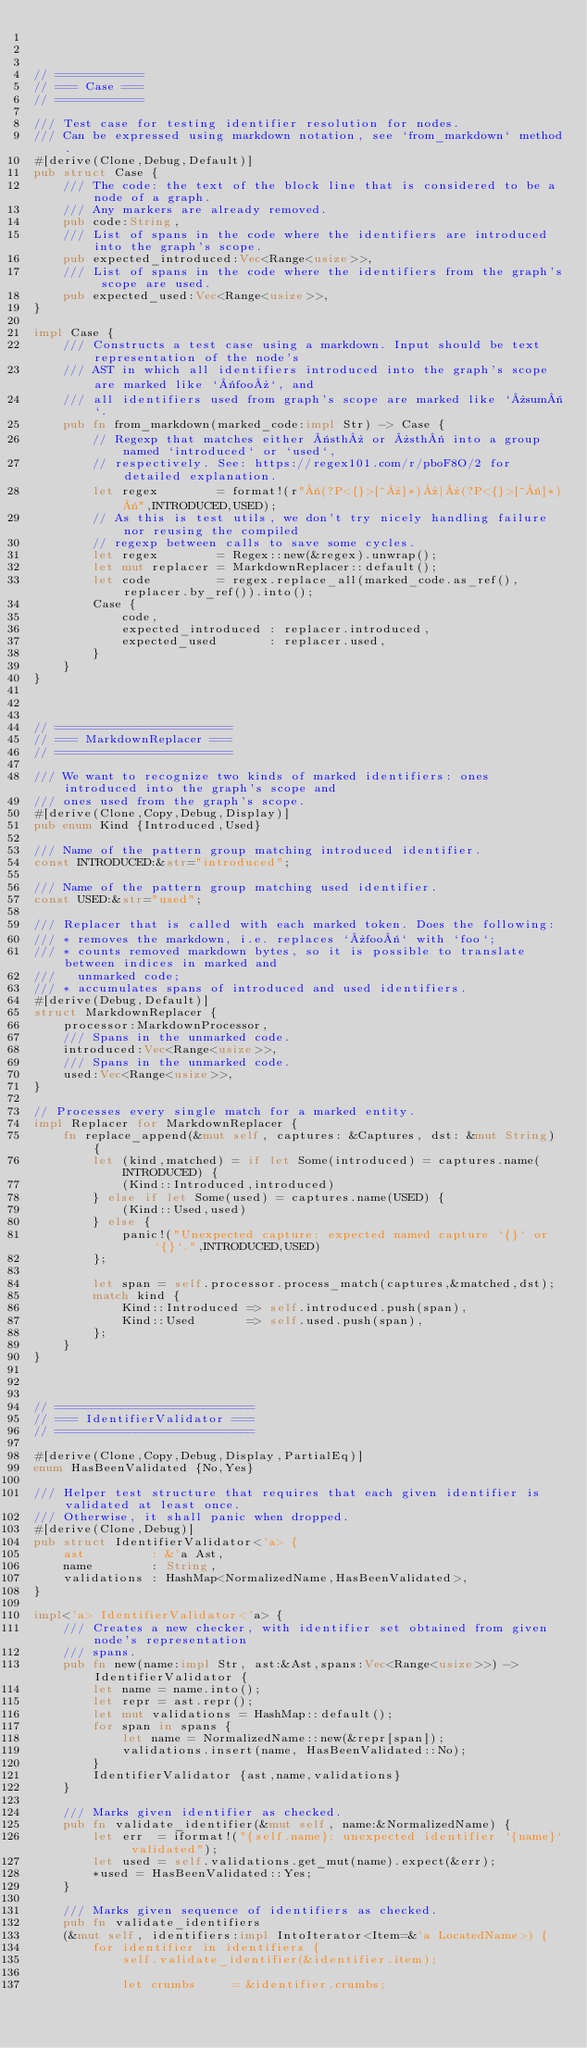<code> <loc_0><loc_0><loc_500><loc_500><_Rust_>


// ============
// === Case ===
// ============

/// Test case for testing identifier resolution for nodes.
/// Can be expressed using markdown notation, see `from_markdown` method.
#[derive(Clone,Debug,Default)]
pub struct Case {
    /// The code: the text of the block line that is considered to be a node of a graph.
    /// Any markers are already removed.
    pub code:String,
    /// List of spans in the code where the identifiers are introduced into the graph's scope.
    pub expected_introduced:Vec<Range<usize>>,
    /// List of spans in the code where the identifiers from the graph's scope are used.
    pub expected_used:Vec<Range<usize>>,
}

impl Case {
    /// Constructs a test case using a markdown. Input should be text representation of the node's
    /// AST in which all identifiers introduced into the graph's scope are marked like `«foo»`, and
    /// all identifiers used from graph's scope are marked like `»sum«`.
    pub fn from_markdown(marked_code:impl Str) -> Case {
        // Regexp that matches either «sth» or »sth« into a group named `introduced` or `used`,
        // respectively. See: https://regex101.com/r/pboF8O/2 for detailed explanation.
        let regex        = format!(r"«(?P<{}>[^»]*)»|»(?P<{}>[^«]*)«",INTRODUCED,USED);
        // As this is test utils, we don't try nicely handling failure nor reusing the compiled
        // regexp between calls to save some cycles.
        let regex        = Regex::new(&regex).unwrap();
        let mut replacer = MarkdownReplacer::default();
        let code         = regex.replace_all(marked_code.as_ref(), replacer.by_ref()).into();
        Case {
            code,
            expected_introduced : replacer.introduced,
            expected_used       : replacer.used,
        }
    }
}



// ========================
// === MarkdownReplacer ===
// ========================

/// We want to recognize two kinds of marked identifiers: ones introduced into the graph's scope and
/// ones used from the graph's scope.
#[derive(Clone,Copy,Debug,Display)]
pub enum Kind {Introduced,Used}

/// Name of the pattern group matching introduced identifier.
const INTRODUCED:&str="introduced";

/// Name of the pattern group matching used identifier.
const USED:&str="used";

/// Replacer that is called with each marked token. Does the following:
/// * removes the markdown, i.e. replaces `»foo«` with `foo`;
/// * counts removed markdown bytes, so it is possible to translate between indices in marked and
///   unmarked code;
/// * accumulates spans of introduced and used identifiers.
#[derive(Debug,Default)]
struct MarkdownReplacer {
    processor:MarkdownProcessor,
    /// Spans in the unmarked code.
    introduced:Vec<Range<usize>>,
    /// Spans in the unmarked code.
    used:Vec<Range<usize>>,
}

// Processes every single match for a marked entity.
impl Replacer for MarkdownReplacer {
    fn replace_append(&mut self, captures: &Captures, dst: &mut String) {
        let (kind,matched) = if let Some(introduced) = captures.name(INTRODUCED) {
            (Kind::Introduced,introduced)
        } else if let Some(used) = captures.name(USED) {
            (Kind::Used,used)
        } else {
            panic!("Unexpected capture: expected named capture `{}` or `{}`.",INTRODUCED,USED)
        };

        let span = self.processor.process_match(captures,&matched,dst);
        match kind {
            Kind::Introduced => self.introduced.push(span),
            Kind::Used       => self.used.push(span),
        };
    }
}



// ===========================
// === IdentifierValidator ===
// ===========================

#[derive(Clone,Copy,Debug,Display,PartialEq)]
enum HasBeenValidated {No,Yes}

/// Helper test structure that requires that each given identifier is validated at least once.
/// Otherwise, it shall panic when dropped.
#[derive(Clone,Debug)]
pub struct IdentifierValidator<'a> {
    ast         : &'a Ast,
    name        : String,
    validations : HashMap<NormalizedName,HasBeenValidated>,
}

impl<'a> IdentifierValidator<'a> {
    /// Creates a new checker, with identifier set obtained from given node's representation
    /// spans.
    pub fn new(name:impl Str, ast:&Ast,spans:Vec<Range<usize>>) -> IdentifierValidator {
        let name = name.into();
        let repr = ast.repr();
        let mut validations = HashMap::default();
        for span in spans {
            let name = NormalizedName::new(&repr[span]);
            validations.insert(name, HasBeenValidated::No);
        }
        IdentifierValidator {ast,name,validations}
    }

    /// Marks given identifier as checked.
    pub fn validate_identifier(&mut self, name:&NormalizedName) {
        let err  = iformat!("{self.name}: unexpected identifier `{name}` validated");
        let used = self.validations.get_mut(name).expect(&err);
        *used = HasBeenValidated::Yes;
    }

    /// Marks given sequence of identifiers as checked.
    pub fn validate_identifiers
    (&mut self, identifiers:impl IntoIterator<Item=&'a LocatedName>) {
        for identifier in identifiers {
            self.validate_identifier(&identifier.item);

            let crumbs     = &identifier.crumbs;</code> 